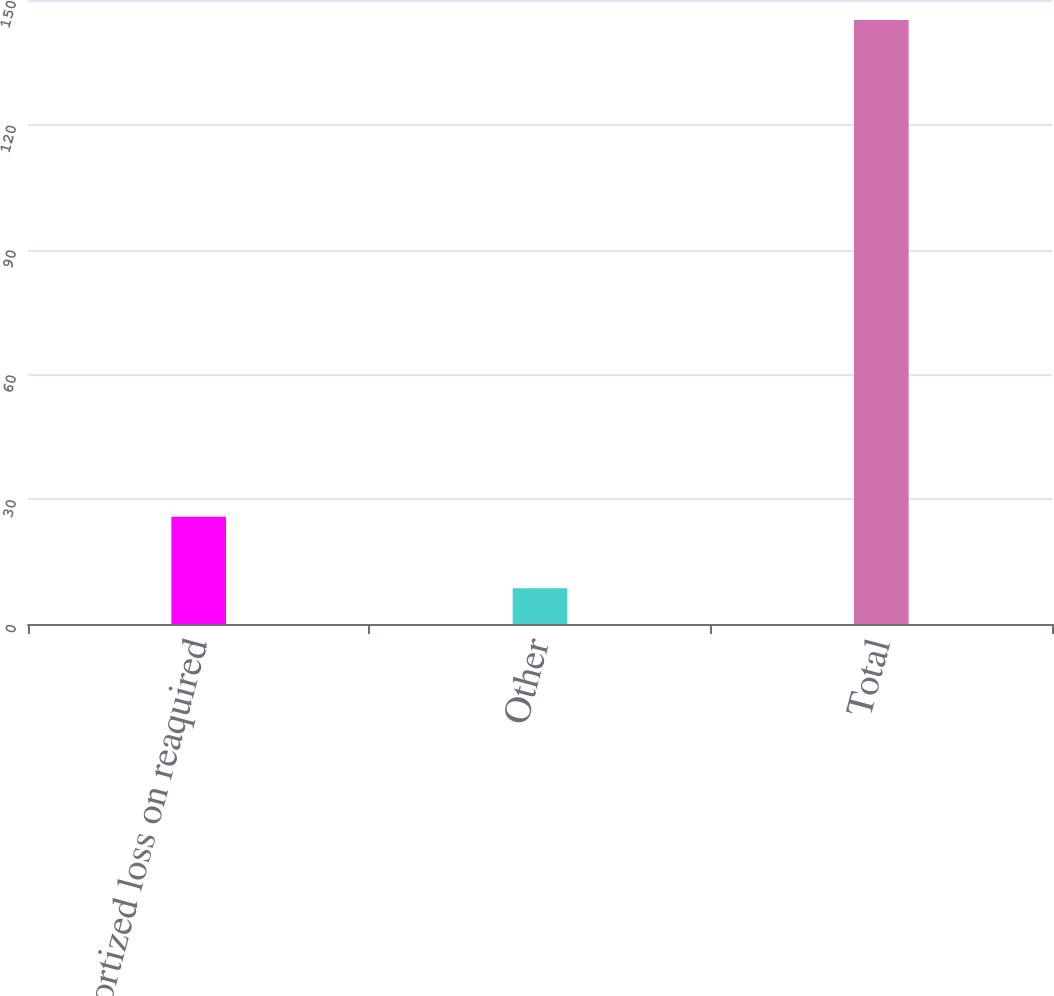<chart> <loc_0><loc_0><loc_500><loc_500><bar_chart><fcel>Unamortized loss on reaquired<fcel>Other<fcel>Total<nl><fcel>25.8<fcel>8.6<fcel>145.2<nl></chart> 